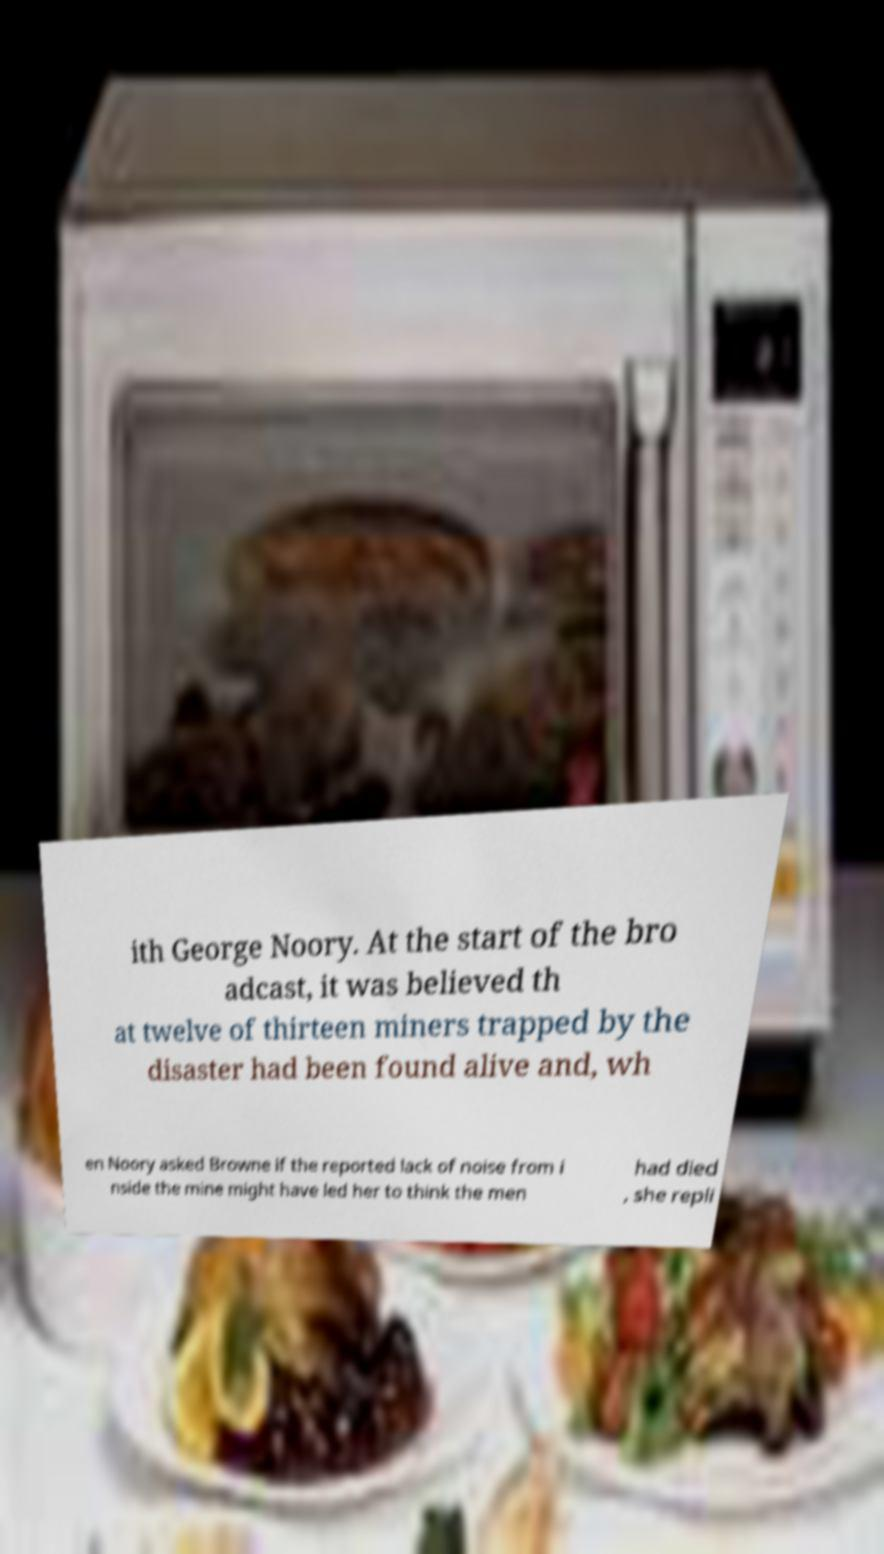Could you extract and type out the text from this image? ith George Noory. At the start of the bro adcast, it was believed th at twelve of thirteen miners trapped by the disaster had been found alive and, wh en Noory asked Browne if the reported lack of noise from i nside the mine might have led her to think the men had died , she repli 